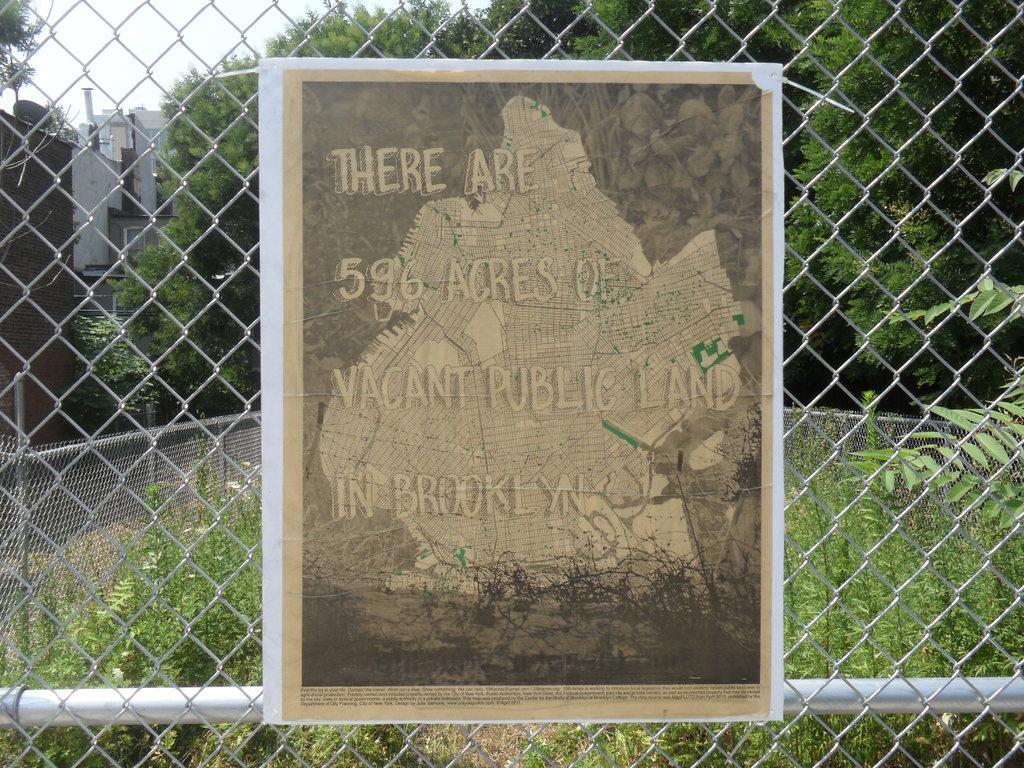Can you describe this image briefly? This is a paper, it is sticked to the iron net. At the back side there are green color trees. 